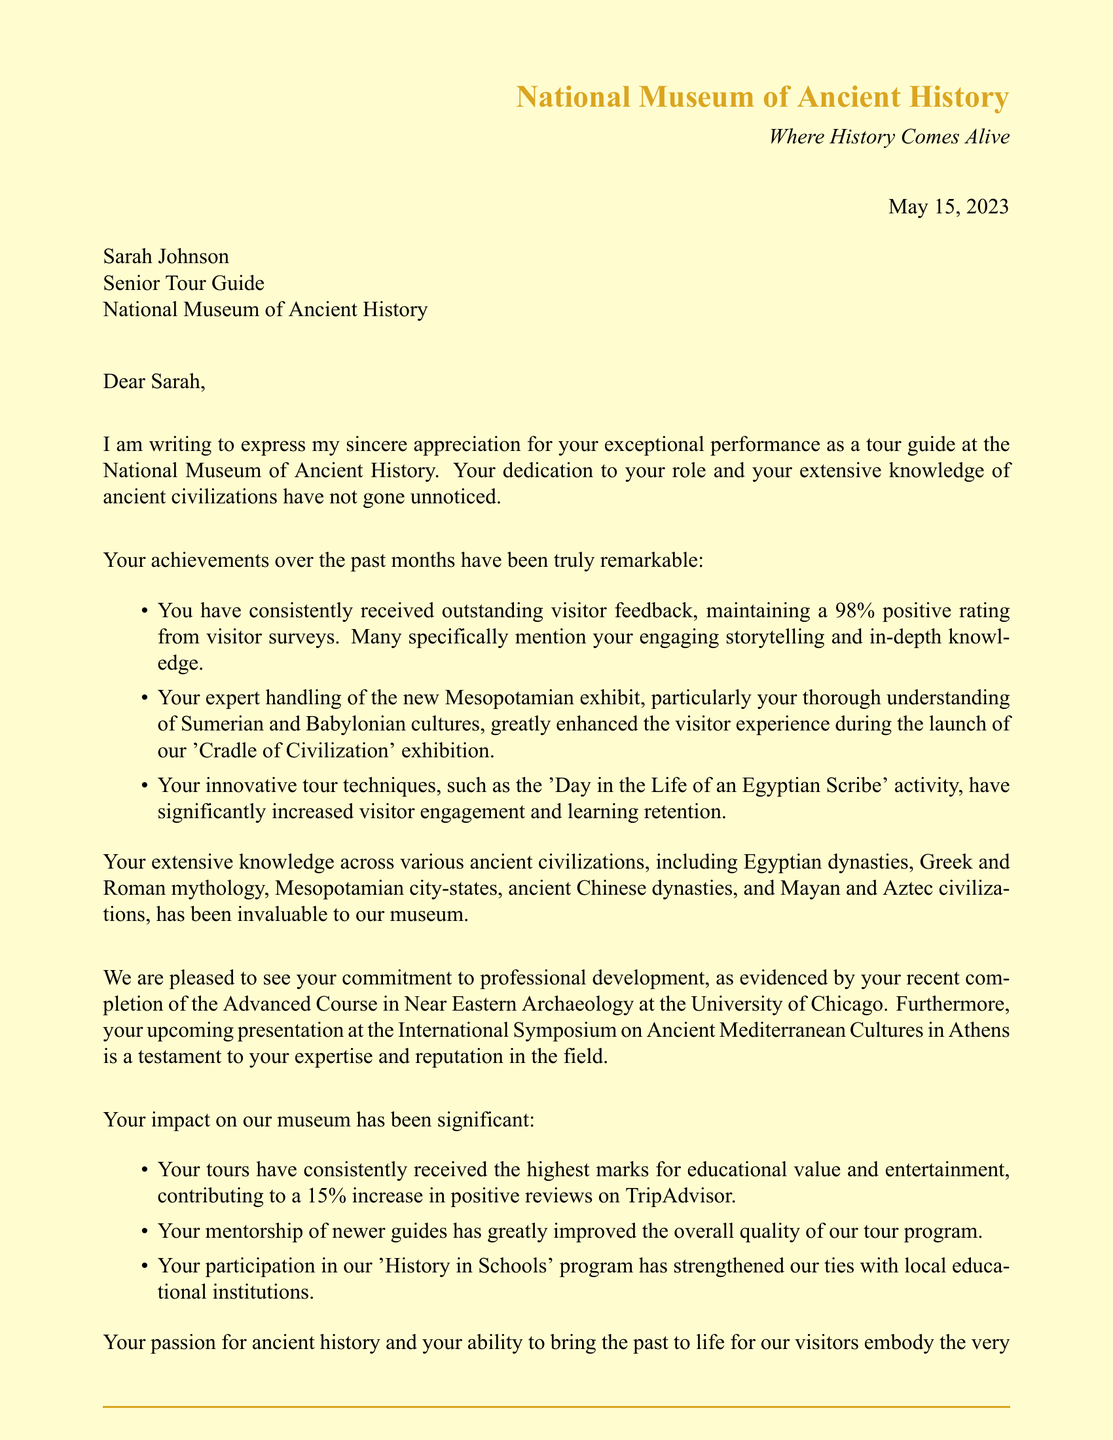What is the name of the museum director? The museum director is explicitly named in the document as Dr. Elizabeth Hawthorne.
Answer: Dr. Elizabeth Hawthorne What was Sarah Johnson's role? Sarah Johnson’s title as mentioned in the document is Senior Tour Guide at the museum.
Answer: Senior Tour Guide What percentage of positive feedback did Sarah maintain? The document states that Sarah maintained a 98% positive rating from visitor surveys.
Answer: 98% What is the title of the new exhibit mentioned? The name of the new exhibit referred to in the document is 'Cradle of Civilization'.
Answer: Cradle of Civilization What innovative activity did Sarah develop? The document describes an activity called 'Day in the Life of an Egyptian Scribe' that Sarah incorporated into her tours.
Answer: Day in the Life of an Egyptian Scribe Where did Sarah complete her recent training? The document provides information that she completed the Advanced Course in Near Eastern Archaeology at the University of Chicago.
Answer: University of Chicago What contribution to TripAdvisor feedback did Sarah's tours have? The document mentions that her tours contributed to a 15% increase in positive reviews on TripAdvisor.
Answer: 15% What upcoming event is mentioned for Sarah? It is stated in the document that she has an invitation to present at the International Symposium on Ancient Mediterranean Cultures in Athens.
Answer: International Symposium on Ancient Mediterranean Cultures in Athens What impact did Sarah have on newer guides? The document notes that her mentorship has greatly benefited newer guides and improved the quality of the tour program.
Answer: Improved the quality of the tour program 